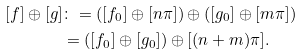<formula> <loc_0><loc_0><loc_500><loc_500>[ f ] \oplus [ g ] & \colon = ( [ f _ { 0 } ] \oplus [ n \pi ] ) \oplus ( [ g _ { 0 } ] \oplus [ m \pi ] ) \\ & = ( [ f _ { 0 } ] \oplus [ g _ { 0 } ] ) \oplus [ ( n + m ) \pi ] .</formula> 